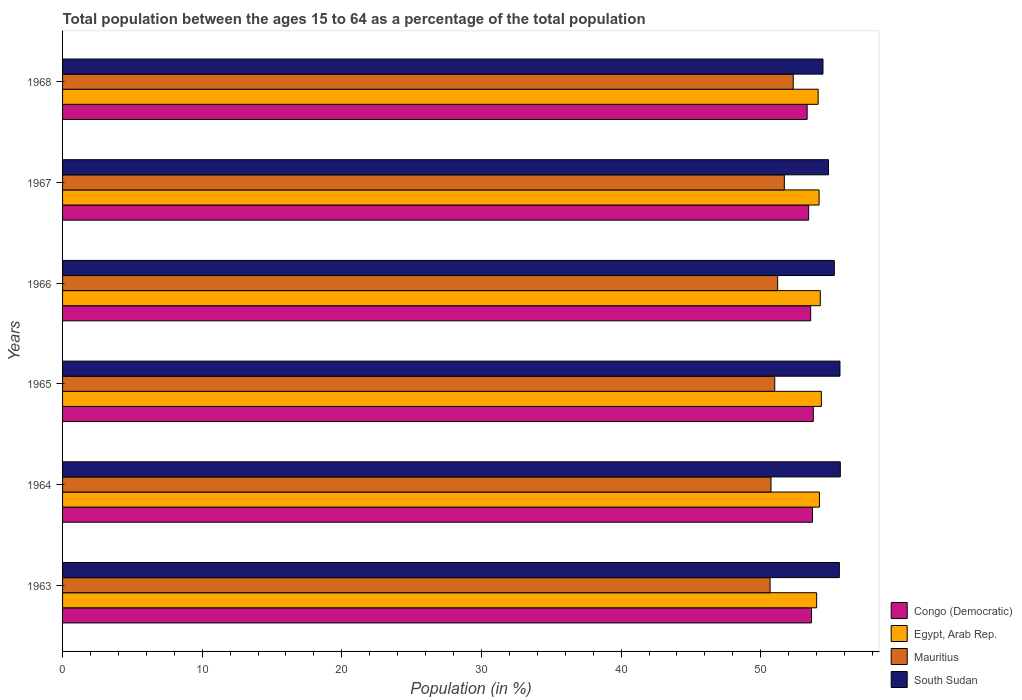Are the number of bars on each tick of the Y-axis equal?
Keep it short and to the point. Yes. How many bars are there on the 6th tick from the top?
Your answer should be compact. 4. How many bars are there on the 1st tick from the bottom?
Make the answer very short. 4. What is the label of the 1st group of bars from the top?
Keep it short and to the point. 1968. What is the percentage of the population ages 15 to 64 in South Sudan in 1964?
Your answer should be compact. 55.7. Across all years, what is the maximum percentage of the population ages 15 to 64 in Congo (Democratic)?
Ensure brevity in your answer.  53.77. Across all years, what is the minimum percentage of the population ages 15 to 64 in Egypt, Arab Rep.?
Your response must be concise. 54.01. In which year was the percentage of the population ages 15 to 64 in Congo (Democratic) maximum?
Your response must be concise. 1965. In which year was the percentage of the population ages 15 to 64 in Congo (Democratic) minimum?
Your response must be concise. 1968. What is the total percentage of the population ages 15 to 64 in Egypt, Arab Rep. in the graph?
Your response must be concise. 325.12. What is the difference between the percentage of the population ages 15 to 64 in South Sudan in 1966 and that in 1967?
Your response must be concise. 0.42. What is the difference between the percentage of the population ages 15 to 64 in Congo (Democratic) in 1967 and the percentage of the population ages 15 to 64 in Egypt, Arab Rep. in 1968?
Make the answer very short. -0.68. What is the average percentage of the population ages 15 to 64 in Congo (Democratic) per year?
Ensure brevity in your answer.  53.58. In the year 1968, what is the difference between the percentage of the population ages 15 to 64 in Egypt, Arab Rep. and percentage of the population ages 15 to 64 in Congo (Democratic)?
Keep it short and to the point. 0.79. In how many years, is the percentage of the population ages 15 to 64 in South Sudan greater than 50 ?
Your answer should be compact. 6. What is the ratio of the percentage of the population ages 15 to 64 in Egypt, Arab Rep. in 1963 to that in 1966?
Offer a very short reply. 1. Is the percentage of the population ages 15 to 64 in Egypt, Arab Rep. in 1963 less than that in 1965?
Offer a very short reply. Yes. What is the difference between the highest and the second highest percentage of the population ages 15 to 64 in Egypt, Arab Rep.?
Keep it short and to the point. 0.08. What is the difference between the highest and the lowest percentage of the population ages 15 to 64 in Egypt, Arab Rep.?
Provide a succinct answer. 0.34. In how many years, is the percentage of the population ages 15 to 64 in Congo (Democratic) greater than the average percentage of the population ages 15 to 64 in Congo (Democratic) taken over all years?
Offer a very short reply. 4. Is it the case that in every year, the sum of the percentage of the population ages 15 to 64 in South Sudan and percentage of the population ages 15 to 64 in Egypt, Arab Rep. is greater than the sum of percentage of the population ages 15 to 64 in Mauritius and percentage of the population ages 15 to 64 in Congo (Democratic)?
Provide a succinct answer. Yes. What does the 2nd bar from the top in 1966 represents?
Ensure brevity in your answer.  Mauritius. What does the 2nd bar from the bottom in 1965 represents?
Provide a succinct answer. Egypt, Arab Rep. Is it the case that in every year, the sum of the percentage of the population ages 15 to 64 in Congo (Democratic) and percentage of the population ages 15 to 64 in Egypt, Arab Rep. is greater than the percentage of the population ages 15 to 64 in Mauritius?
Offer a very short reply. Yes. Are all the bars in the graph horizontal?
Ensure brevity in your answer.  Yes. What is the difference between two consecutive major ticks on the X-axis?
Offer a very short reply. 10. Does the graph contain grids?
Make the answer very short. No. Where does the legend appear in the graph?
Keep it short and to the point. Bottom right. How many legend labels are there?
Provide a succinct answer. 4. How are the legend labels stacked?
Your answer should be very brief. Vertical. What is the title of the graph?
Offer a very short reply. Total population between the ages 15 to 64 as a percentage of the total population. What is the Population (in %) in Congo (Democratic) in 1963?
Your answer should be very brief. 53.64. What is the Population (in %) of Egypt, Arab Rep. in 1963?
Your answer should be very brief. 54.01. What is the Population (in %) of Mauritius in 1963?
Provide a short and direct response. 50.67. What is the Population (in %) of South Sudan in 1963?
Keep it short and to the point. 55.63. What is the Population (in %) of Congo (Democratic) in 1964?
Your response must be concise. 53.71. What is the Population (in %) in Egypt, Arab Rep. in 1964?
Offer a very short reply. 54.21. What is the Population (in %) in Mauritius in 1964?
Make the answer very short. 50.74. What is the Population (in %) in South Sudan in 1964?
Your answer should be very brief. 55.7. What is the Population (in %) of Congo (Democratic) in 1965?
Ensure brevity in your answer.  53.77. What is the Population (in %) in Egypt, Arab Rep. in 1965?
Your response must be concise. 54.34. What is the Population (in %) of Mauritius in 1965?
Your response must be concise. 51.01. What is the Population (in %) in South Sudan in 1965?
Your answer should be compact. 55.68. What is the Population (in %) in Congo (Democratic) in 1966?
Your answer should be compact. 53.58. What is the Population (in %) in Egypt, Arab Rep. in 1966?
Your answer should be very brief. 54.27. What is the Population (in %) of Mauritius in 1966?
Your answer should be compact. 51.21. What is the Population (in %) of South Sudan in 1966?
Give a very brief answer. 55.27. What is the Population (in %) in Congo (Democratic) in 1967?
Offer a terse response. 53.43. What is the Population (in %) of Egypt, Arab Rep. in 1967?
Keep it short and to the point. 54.18. What is the Population (in %) in Mauritius in 1967?
Make the answer very short. 51.69. What is the Population (in %) in South Sudan in 1967?
Provide a short and direct response. 54.85. What is the Population (in %) of Congo (Democratic) in 1968?
Offer a very short reply. 53.33. What is the Population (in %) in Egypt, Arab Rep. in 1968?
Your answer should be compact. 54.11. What is the Population (in %) of Mauritius in 1968?
Provide a short and direct response. 52.33. What is the Population (in %) of South Sudan in 1968?
Provide a short and direct response. 54.46. Across all years, what is the maximum Population (in %) in Congo (Democratic)?
Your answer should be compact. 53.77. Across all years, what is the maximum Population (in %) in Egypt, Arab Rep.?
Your answer should be very brief. 54.34. Across all years, what is the maximum Population (in %) in Mauritius?
Provide a short and direct response. 52.33. Across all years, what is the maximum Population (in %) in South Sudan?
Ensure brevity in your answer.  55.7. Across all years, what is the minimum Population (in %) of Congo (Democratic)?
Provide a short and direct response. 53.33. Across all years, what is the minimum Population (in %) of Egypt, Arab Rep.?
Give a very brief answer. 54.01. Across all years, what is the minimum Population (in %) of Mauritius?
Provide a succinct answer. 50.67. Across all years, what is the minimum Population (in %) in South Sudan?
Your answer should be compact. 54.46. What is the total Population (in %) in Congo (Democratic) in the graph?
Provide a short and direct response. 321.45. What is the total Population (in %) in Egypt, Arab Rep. in the graph?
Your answer should be very brief. 325.12. What is the total Population (in %) in Mauritius in the graph?
Provide a short and direct response. 307.65. What is the total Population (in %) of South Sudan in the graph?
Provide a succinct answer. 331.6. What is the difference between the Population (in %) of Congo (Democratic) in 1963 and that in 1964?
Provide a succinct answer. -0.07. What is the difference between the Population (in %) in Egypt, Arab Rep. in 1963 and that in 1964?
Your answer should be compact. -0.2. What is the difference between the Population (in %) in Mauritius in 1963 and that in 1964?
Provide a short and direct response. -0.07. What is the difference between the Population (in %) in South Sudan in 1963 and that in 1964?
Your answer should be compact. -0.07. What is the difference between the Population (in %) in Congo (Democratic) in 1963 and that in 1965?
Ensure brevity in your answer.  -0.13. What is the difference between the Population (in %) of Egypt, Arab Rep. in 1963 and that in 1965?
Give a very brief answer. -0.34. What is the difference between the Population (in %) of Mauritius in 1963 and that in 1965?
Provide a succinct answer. -0.33. What is the difference between the Population (in %) in South Sudan in 1963 and that in 1965?
Your answer should be compact. -0.04. What is the difference between the Population (in %) of Congo (Democratic) in 1963 and that in 1966?
Your response must be concise. 0.06. What is the difference between the Population (in %) of Egypt, Arab Rep. in 1963 and that in 1966?
Your answer should be compact. -0.26. What is the difference between the Population (in %) of Mauritius in 1963 and that in 1966?
Provide a short and direct response. -0.54. What is the difference between the Population (in %) in South Sudan in 1963 and that in 1966?
Give a very brief answer. 0.36. What is the difference between the Population (in %) of Congo (Democratic) in 1963 and that in 1967?
Your answer should be very brief. 0.2. What is the difference between the Population (in %) of Egypt, Arab Rep. in 1963 and that in 1967?
Provide a succinct answer. -0.18. What is the difference between the Population (in %) in Mauritius in 1963 and that in 1967?
Your answer should be compact. -1.02. What is the difference between the Population (in %) in South Sudan in 1963 and that in 1967?
Ensure brevity in your answer.  0.78. What is the difference between the Population (in %) in Congo (Democratic) in 1963 and that in 1968?
Provide a short and direct response. 0.31. What is the difference between the Population (in %) of Egypt, Arab Rep. in 1963 and that in 1968?
Your response must be concise. -0.11. What is the difference between the Population (in %) in Mauritius in 1963 and that in 1968?
Provide a succinct answer. -1.66. What is the difference between the Population (in %) of South Sudan in 1963 and that in 1968?
Your response must be concise. 1.17. What is the difference between the Population (in %) of Congo (Democratic) in 1964 and that in 1965?
Offer a very short reply. -0.06. What is the difference between the Population (in %) in Egypt, Arab Rep. in 1964 and that in 1965?
Provide a succinct answer. -0.14. What is the difference between the Population (in %) of Mauritius in 1964 and that in 1965?
Make the answer very short. -0.27. What is the difference between the Population (in %) of South Sudan in 1964 and that in 1965?
Give a very brief answer. 0.02. What is the difference between the Population (in %) in Congo (Democratic) in 1964 and that in 1966?
Offer a very short reply. 0.13. What is the difference between the Population (in %) of Egypt, Arab Rep. in 1964 and that in 1966?
Make the answer very short. -0.06. What is the difference between the Population (in %) of Mauritius in 1964 and that in 1966?
Make the answer very short. -0.48. What is the difference between the Population (in %) in South Sudan in 1964 and that in 1966?
Ensure brevity in your answer.  0.43. What is the difference between the Population (in %) in Congo (Democratic) in 1964 and that in 1967?
Give a very brief answer. 0.27. What is the difference between the Population (in %) in Egypt, Arab Rep. in 1964 and that in 1967?
Keep it short and to the point. 0.03. What is the difference between the Population (in %) in Mauritius in 1964 and that in 1967?
Provide a short and direct response. -0.95. What is the difference between the Population (in %) of South Sudan in 1964 and that in 1967?
Offer a very short reply. 0.85. What is the difference between the Population (in %) of Congo (Democratic) in 1964 and that in 1968?
Give a very brief answer. 0.38. What is the difference between the Population (in %) in Egypt, Arab Rep. in 1964 and that in 1968?
Your answer should be very brief. 0.09. What is the difference between the Population (in %) of Mauritius in 1964 and that in 1968?
Make the answer very short. -1.59. What is the difference between the Population (in %) in South Sudan in 1964 and that in 1968?
Give a very brief answer. 1.24. What is the difference between the Population (in %) of Congo (Democratic) in 1965 and that in 1966?
Make the answer very short. 0.19. What is the difference between the Population (in %) in Egypt, Arab Rep. in 1965 and that in 1966?
Keep it short and to the point. 0.08. What is the difference between the Population (in %) of Mauritius in 1965 and that in 1966?
Offer a terse response. -0.21. What is the difference between the Population (in %) in South Sudan in 1965 and that in 1966?
Your answer should be compact. 0.41. What is the difference between the Population (in %) of Congo (Democratic) in 1965 and that in 1967?
Your response must be concise. 0.33. What is the difference between the Population (in %) of Egypt, Arab Rep. in 1965 and that in 1967?
Your answer should be very brief. 0.16. What is the difference between the Population (in %) of Mauritius in 1965 and that in 1967?
Provide a short and direct response. -0.69. What is the difference between the Population (in %) in South Sudan in 1965 and that in 1967?
Give a very brief answer. 0.82. What is the difference between the Population (in %) in Congo (Democratic) in 1965 and that in 1968?
Make the answer very short. 0.44. What is the difference between the Population (in %) in Egypt, Arab Rep. in 1965 and that in 1968?
Offer a terse response. 0.23. What is the difference between the Population (in %) of Mauritius in 1965 and that in 1968?
Offer a terse response. -1.32. What is the difference between the Population (in %) in South Sudan in 1965 and that in 1968?
Offer a very short reply. 1.22. What is the difference between the Population (in %) of Congo (Democratic) in 1966 and that in 1967?
Offer a terse response. 0.14. What is the difference between the Population (in %) in Egypt, Arab Rep. in 1966 and that in 1967?
Make the answer very short. 0.09. What is the difference between the Population (in %) in Mauritius in 1966 and that in 1967?
Give a very brief answer. -0.48. What is the difference between the Population (in %) in South Sudan in 1966 and that in 1967?
Keep it short and to the point. 0.42. What is the difference between the Population (in %) in Congo (Democratic) in 1966 and that in 1968?
Provide a short and direct response. 0.25. What is the difference between the Population (in %) of Egypt, Arab Rep. in 1966 and that in 1968?
Give a very brief answer. 0.15. What is the difference between the Population (in %) in Mauritius in 1966 and that in 1968?
Your answer should be very brief. -1.11. What is the difference between the Population (in %) in South Sudan in 1966 and that in 1968?
Your answer should be very brief. 0.81. What is the difference between the Population (in %) of Congo (Democratic) in 1967 and that in 1968?
Offer a terse response. 0.11. What is the difference between the Population (in %) in Egypt, Arab Rep. in 1967 and that in 1968?
Offer a very short reply. 0.07. What is the difference between the Population (in %) in Mauritius in 1967 and that in 1968?
Your answer should be very brief. -0.64. What is the difference between the Population (in %) of South Sudan in 1967 and that in 1968?
Ensure brevity in your answer.  0.39. What is the difference between the Population (in %) of Congo (Democratic) in 1963 and the Population (in %) of Egypt, Arab Rep. in 1964?
Make the answer very short. -0.57. What is the difference between the Population (in %) in Congo (Democratic) in 1963 and the Population (in %) in Mauritius in 1964?
Your answer should be compact. 2.9. What is the difference between the Population (in %) of Congo (Democratic) in 1963 and the Population (in %) of South Sudan in 1964?
Your answer should be compact. -2.06. What is the difference between the Population (in %) of Egypt, Arab Rep. in 1963 and the Population (in %) of Mauritius in 1964?
Your answer should be very brief. 3.27. What is the difference between the Population (in %) of Egypt, Arab Rep. in 1963 and the Population (in %) of South Sudan in 1964?
Ensure brevity in your answer.  -1.7. What is the difference between the Population (in %) of Mauritius in 1963 and the Population (in %) of South Sudan in 1964?
Your answer should be very brief. -5.03. What is the difference between the Population (in %) of Congo (Democratic) in 1963 and the Population (in %) of Egypt, Arab Rep. in 1965?
Give a very brief answer. -0.71. What is the difference between the Population (in %) of Congo (Democratic) in 1963 and the Population (in %) of Mauritius in 1965?
Your answer should be very brief. 2.63. What is the difference between the Population (in %) of Congo (Democratic) in 1963 and the Population (in %) of South Sudan in 1965?
Provide a succinct answer. -2.04. What is the difference between the Population (in %) of Egypt, Arab Rep. in 1963 and the Population (in %) of Mauritius in 1965?
Ensure brevity in your answer.  3. What is the difference between the Population (in %) in Egypt, Arab Rep. in 1963 and the Population (in %) in South Sudan in 1965?
Your response must be concise. -1.67. What is the difference between the Population (in %) of Mauritius in 1963 and the Population (in %) of South Sudan in 1965?
Provide a succinct answer. -5. What is the difference between the Population (in %) of Congo (Democratic) in 1963 and the Population (in %) of Egypt, Arab Rep. in 1966?
Your answer should be very brief. -0.63. What is the difference between the Population (in %) of Congo (Democratic) in 1963 and the Population (in %) of Mauritius in 1966?
Provide a short and direct response. 2.42. What is the difference between the Population (in %) of Congo (Democratic) in 1963 and the Population (in %) of South Sudan in 1966?
Give a very brief answer. -1.63. What is the difference between the Population (in %) in Egypt, Arab Rep. in 1963 and the Population (in %) in Mauritius in 1966?
Your answer should be compact. 2.79. What is the difference between the Population (in %) in Egypt, Arab Rep. in 1963 and the Population (in %) in South Sudan in 1966?
Provide a short and direct response. -1.27. What is the difference between the Population (in %) in Mauritius in 1963 and the Population (in %) in South Sudan in 1966?
Your answer should be very brief. -4.6. What is the difference between the Population (in %) of Congo (Democratic) in 1963 and the Population (in %) of Egypt, Arab Rep. in 1967?
Provide a short and direct response. -0.54. What is the difference between the Population (in %) of Congo (Democratic) in 1963 and the Population (in %) of Mauritius in 1967?
Provide a succinct answer. 1.95. What is the difference between the Population (in %) in Congo (Democratic) in 1963 and the Population (in %) in South Sudan in 1967?
Offer a terse response. -1.22. What is the difference between the Population (in %) in Egypt, Arab Rep. in 1963 and the Population (in %) in Mauritius in 1967?
Your answer should be compact. 2.31. What is the difference between the Population (in %) of Egypt, Arab Rep. in 1963 and the Population (in %) of South Sudan in 1967?
Ensure brevity in your answer.  -0.85. What is the difference between the Population (in %) of Mauritius in 1963 and the Population (in %) of South Sudan in 1967?
Your answer should be very brief. -4.18. What is the difference between the Population (in %) in Congo (Democratic) in 1963 and the Population (in %) in Egypt, Arab Rep. in 1968?
Offer a very short reply. -0.48. What is the difference between the Population (in %) of Congo (Democratic) in 1963 and the Population (in %) of Mauritius in 1968?
Make the answer very short. 1.31. What is the difference between the Population (in %) in Congo (Democratic) in 1963 and the Population (in %) in South Sudan in 1968?
Your answer should be compact. -0.82. What is the difference between the Population (in %) in Egypt, Arab Rep. in 1963 and the Population (in %) in Mauritius in 1968?
Keep it short and to the point. 1.68. What is the difference between the Population (in %) in Egypt, Arab Rep. in 1963 and the Population (in %) in South Sudan in 1968?
Provide a short and direct response. -0.45. What is the difference between the Population (in %) of Mauritius in 1963 and the Population (in %) of South Sudan in 1968?
Offer a very short reply. -3.79. What is the difference between the Population (in %) of Congo (Democratic) in 1964 and the Population (in %) of Egypt, Arab Rep. in 1965?
Your answer should be compact. -0.64. What is the difference between the Population (in %) in Congo (Democratic) in 1964 and the Population (in %) in Mauritius in 1965?
Offer a terse response. 2.7. What is the difference between the Population (in %) of Congo (Democratic) in 1964 and the Population (in %) of South Sudan in 1965?
Provide a short and direct response. -1.97. What is the difference between the Population (in %) in Egypt, Arab Rep. in 1964 and the Population (in %) in Mauritius in 1965?
Keep it short and to the point. 3.2. What is the difference between the Population (in %) of Egypt, Arab Rep. in 1964 and the Population (in %) of South Sudan in 1965?
Your answer should be compact. -1.47. What is the difference between the Population (in %) of Mauritius in 1964 and the Population (in %) of South Sudan in 1965?
Ensure brevity in your answer.  -4.94. What is the difference between the Population (in %) of Congo (Democratic) in 1964 and the Population (in %) of Egypt, Arab Rep. in 1966?
Keep it short and to the point. -0.56. What is the difference between the Population (in %) in Congo (Democratic) in 1964 and the Population (in %) in Mauritius in 1966?
Provide a succinct answer. 2.49. What is the difference between the Population (in %) in Congo (Democratic) in 1964 and the Population (in %) in South Sudan in 1966?
Keep it short and to the point. -1.56. What is the difference between the Population (in %) in Egypt, Arab Rep. in 1964 and the Population (in %) in Mauritius in 1966?
Offer a terse response. 2.99. What is the difference between the Population (in %) in Egypt, Arab Rep. in 1964 and the Population (in %) in South Sudan in 1966?
Your answer should be compact. -1.06. What is the difference between the Population (in %) of Mauritius in 1964 and the Population (in %) of South Sudan in 1966?
Your answer should be very brief. -4.53. What is the difference between the Population (in %) in Congo (Democratic) in 1964 and the Population (in %) in Egypt, Arab Rep. in 1967?
Your answer should be compact. -0.47. What is the difference between the Population (in %) in Congo (Democratic) in 1964 and the Population (in %) in Mauritius in 1967?
Provide a succinct answer. 2.02. What is the difference between the Population (in %) of Congo (Democratic) in 1964 and the Population (in %) of South Sudan in 1967?
Offer a terse response. -1.15. What is the difference between the Population (in %) of Egypt, Arab Rep. in 1964 and the Population (in %) of Mauritius in 1967?
Keep it short and to the point. 2.52. What is the difference between the Population (in %) in Egypt, Arab Rep. in 1964 and the Population (in %) in South Sudan in 1967?
Make the answer very short. -0.65. What is the difference between the Population (in %) of Mauritius in 1964 and the Population (in %) of South Sudan in 1967?
Offer a terse response. -4.12. What is the difference between the Population (in %) in Congo (Democratic) in 1964 and the Population (in %) in Egypt, Arab Rep. in 1968?
Ensure brevity in your answer.  -0.41. What is the difference between the Population (in %) of Congo (Democratic) in 1964 and the Population (in %) of Mauritius in 1968?
Make the answer very short. 1.38. What is the difference between the Population (in %) in Congo (Democratic) in 1964 and the Population (in %) in South Sudan in 1968?
Your response must be concise. -0.75. What is the difference between the Population (in %) in Egypt, Arab Rep. in 1964 and the Population (in %) in Mauritius in 1968?
Give a very brief answer. 1.88. What is the difference between the Population (in %) of Egypt, Arab Rep. in 1964 and the Population (in %) of South Sudan in 1968?
Offer a very short reply. -0.25. What is the difference between the Population (in %) in Mauritius in 1964 and the Population (in %) in South Sudan in 1968?
Ensure brevity in your answer.  -3.72. What is the difference between the Population (in %) of Congo (Democratic) in 1965 and the Population (in %) of Egypt, Arab Rep. in 1966?
Offer a terse response. -0.5. What is the difference between the Population (in %) of Congo (Democratic) in 1965 and the Population (in %) of Mauritius in 1966?
Give a very brief answer. 2.55. What is the difference between the Population (in %) of Congo (Democratic) in 1965 and the Population (in %) of South Sudan in 1966?
Give a very brief answer. -1.5. What is the difference between the Population (in %) of Egypt, Arab Rep. in 1965 and the Population (in %) of Mauritius in 1966?
Make the answer very short. 3.13. What is the difference between the Population (in %) of Egypt, Arab Rep. in 1965 and the Population (in %) of South Sudan in 1966?
Keep it short and to the point. -0.93. What is the difference between the Population (in %) of Mauritius in 1965 and the Population (in %) of South Sudan in 1966?
Make the answer very short. -4.27. What is the difference between the Population (in %) of Congo (Democratic) in 1965 and the Population (in %) of Egypt, Arab Rep. in 1967?
Offer a terse response. -0.42. What is the difference between the Population (in %) of Congo (Democratic) in 1965 and the Population (in %) of Mauritius in 1967?
Provide a short and direct response. 2.07. What is the difference between the Population (in %) of Congo (Democratic) in 1965 and the Population (in %) of South Sudan in 1967?
Your answer should be compact. -1.09. What is the difference between the Population (in %) in Egypt, Arab Rep. in 1965 and the Population (in %) in Mauritius in 1967?
Provide a short and direct response. 2.65. What is the difference between the Population (in %) in Egypt, Arab Rep. in 1965 and the Population (in %) in South Sudan in 1967?
Provide a short and direct response. -0.51. What is the difference between the Population (in %) in Mauritius in 1965 and the Population (in %) in South Sudan in 1967?
Provide a succinct answer. -3.85. What is the difference between the Population (in %) in Congo (Democratic) in 1965 and the Population (in %) in Egypt, Arab Rep. in 1968?
Give a very brief answer. -0.35. What is the difference between the Population (in %) of Congo (Democratic) in 1965 and the Population (in %) of Mauritius in 1968?
Your answer should be very brief. 1.44. What is the difference between the Population (in %) of Congo (Democratic) in 1965 and the Population (in %) of South Sudan in 1968?
Offer a terse response. -0.69. What is the difference between the Population (in %) in Egypt, Arab Rep. in 1965 and the Population (in %) in Mauritius in 1968?
Your response must be concise. 2.01. What is the difference between the Population (in %) in Egypt, Arab Rep. in 1965 and the Population (in %) in South Sudan in 1968?
Make the answer very short. -0.12. What is the difference between the Population (in %) of Mauritius in 1965 and the Population (in %) of South Sudan in 1968?
Offer a very short reply. -3.46. What is the difference between the Population (in %) of Congo (Democratic) in 1966 and the Population (in %) of Egypt, Arab Rep. in 1967?
Your answer should be very brief. -0.6. What is the difference between the Population (in %) in Congo (Democratic) in 1966 and the Population (in %) in Mauritius in 1967?
Your response must be concise. 1.89. What is the difference between the Population (in %) in Congo (Democratic) in 1966 and the Population (in %) in South Sudan in 1967?
Give a very brief answer. -1.27. What is the difference between the Population (in %) of Egypt, Arab Rep. in 1966 and the Population (in %) of Mauritius in 1967?
Give a very brief answer. 2.58. What is the difference between the Population (in %) of Egypt, Arab Rep. in 1966 and the Population (in %) of South Sudan in 1967?
Ensure brevity in your answer.  -0.59. What is the difference between the Population (in %) of Mauritius in 1966 and the Population (in %) of South Sudan in 1967?
Keep it short and to the point. -3.64. What is the difference between the Population (in %) of Congo (Democratic) in 1966 and the Population (in %) of Egypt, Arab Rep. in 1968?
Offer a very short reply. -0.54. What is the difference between the Population (in %) in Congo (Democratic) in 1966 and the Population (in %) in Mauritius in 1968?
Offer a very short reply. 1.25. What is the difference between the Population (in %) of Congo (Democratic) in 1966 and the Population (in %) of South Sudan in 1968?
Your answer should be very brief. -0.88. What is the difference between the Population (in %) in Egypt, Arab Rep. in 1966 and the Population (in %) in Mauritius in 1968?
Make the answer very short. 1.94. What is the difference between the Population (in %) of Egypt, Arab Rep. in 1966 and the Population (in %) of South Sudan in 1968?
Your answer should be very brief. -0.19. What is the difference between the Population (in %) of Mauritius in 1966 and the Population (in %) of South Sudan in 1968?
Ensure brevity in your answer.  -3.25. What is the difference between the Population (in %) in Congo (Democratic) in 1967 and the Population (in %) in Egypt, Arab Rep. in 1968?
Make the answer very short. -0.68. What is the difference between the Population (in %) in Congo (Democratic) in 1967 and the Population (in %) in Mauritius in 1968?
Keep it short and to the point. 1.11. What is the difference between the Population (in %) in Congo (Democratic) in 1967 and the Population (in %) in South Sudan in 1968?
Give a very brief answer. -1.03. What is the difference between the Population (in %) in Egypt, Arab Rep. in 1967 and the Population (in %) in Mauritius in 1968?
Offer a terse response. 1.85. What is the difference between the Population (in %) in Egypt, Arab Rep. in 1967 and the Population (in %) in South Sudan in 1968?
Ensure brevity in your answer.  -0.28. What is the difference between the Population (in %) in Mauritius in 1967 and the Population (in %) in South Sudan in 1968?
Keep it short and to the point. -2.77. What is the average Population (in %) in Congo (Democratic) per year?
Offer a very short reply. 53.58. What is the average Population (in %) of Egypt, Arab Rep. per year?
Keep it short and to the point. 54.19. What is the average Population (in %) of Mauritius per year?
Offer a very short reply. 51.28. What is the average Population (in %) in South Sudan per year?
Make the answer very short. 55.27. In the year 1963, what is the difference between the Population (in %) in Congo (Democratic) and Population (in %) in Egypt, Arab Rep.?
Keep it short and to the point. -0.37. In the year 1963, what is the difference between the Population (in %) of Congo (Democratic) and Population (in %) of Mauritius?
Ensure brevity in your answer.  2.96. In the year 1963, what is the difference between the Population (in %) of Congo (Democratic) and Population (in %) of South Sudan?
Ensure brevity in your answer.  -2. In the year 1963, what is the difference between the Population (in %) of Egypt, Arab Rep. and Population (in %) of Mauritius?
Ensure brevity in your answer.  3.33. In the year 1963, what is the difference between the Population (in %) of Egypt, Arab Rep. and Population (in %) of South Sudan?
Provide a short and direct response. -1.63. In the year 1963, what is the difference between the Population (in %) in Mauritius and Population (in %) in South Sudan?
Give a very brief answer. -4.96. In the year 1964, what is the difference between the Population (in %) of Congo (Democratic) and Population (in %) of Egypt, Arab Rep.?
Your response must be concise. -0.5. In the year 1964, what is the difference between the Population (in %) of Congo (Democratic) and Population (in %) of Mauritius?
Provide a short and direct response. 2.97. In the year 1964, what is the difference between the Population (in %) of Congo (Democratic) and Population (in %) of South Sudan?
Your answer should be compact. -1.99. In the year 1964, what is the difference between the Population (in %) in Egypt, Arab Rep. and Population (in %) in Mauritius?
Provide a short and direct response. 3.47. In the year 1964, what is the difference between the Population (in %) in Egypt, Arab Rep. and Population (in %) in South Sudan?
Ensure brevity in your answer.  -1.49. In the year 1964, what is the difference between the Population (in %) in Mauritius and Population (in %) in South Sudan?
Make the answer very short. -4.96. In the year 1965, what is the difference between the Population (in %) in Congo (Democratic) and Population (in %) in Egypt, Arab Rep.?
Offer a very short reply. -0.58. In the year 1965, what is the difference between the Population (in %) in Congo (Democratic) and Population (in %) in Mauritius?
Make the answer very short. 2.76. In the year 1965, what is the difference between the Population (in %) in Congo (Democratic) and Population (in %) in South Sudan?
Provide a short and direct response. -1.91. In the year 1965, what is the difference between the Population (in %) in Egypt, Arab Rep. and Population (in %) in Mauritius?
Give a very brief answer. 3.34. In the year 1965, what is the difference between the Population (in %) of Egypt, Arab Rep. and Population (in %) of South Sudan?
Give a very brief answer. -1.33. In the year 1965, what is the difference between the Population (in %) of Mauritius and Population (in %) of South Sudan?
Provide a succinct answer. -4.67. In the year 1966, what is the difference between the Population (in %) in Congo (Democratic) and Population (in %) in Egypt, Arab Rep.?
Ensure brevity in your answer.  -0.69. In the year 1966, what is the difference between the Population (in %) of Congo (Democratic) and Population (in %) of Mauritius?
Offer a very short reply. 2.36. In the year 1966, what is the difference between the Population (in %) in Congo (Democratic) and Population (in %) in South Sudan?
Offer a terse response. -1.69. In the year 1966, what is the difference between the Population (in %) of Egypt, Arab Rep. and Population (in %) of Mauritius?
Ensure brevity in your answer.  3.05. In the year 1966, what is the difference between the Population (in %) of Egypt, Arab Rep. and Population (in %) of South Sudan?
Make the answer very short. -1. In the year 1966, what is the difference between the Population (in %) of Mauritius and Population (in %) of South Sudan?
Ensure brevity in your answer.  -4.06. In the year 1967, what is the difference between the Population (in %) of Congo (Democratic) and Population (in %) of Egypt, Arab Rep.?
Make the answer very short. -0.75. In the year 1967, what is the difference between the Population (in %) of Congo (Democratic) and Population (in %) of Mauritius?
Keep it short and to the point. 1.74. In the year 1967, what is the difference between the Population (in %) in Congo (Democratic) and Population (in %) in South Sudan?
Your answer should be compact. -1.42. In the year 1967, what is the difference between the Population (in %) in Egypt, Arab Rep. and Population (in %) in Mauritius?
Give a very brief answer. 2.49. In the year 1967, what is the difference between the Population (in %) in Egypt, Arab Rep. and Population (in %) in South Sudan?
Offer a very short reply. -0.67. In the year 1967, what is the difference between the Population (in %) in Mauritius and Population (in %) in South Sudan?
Give a very brief answer. -3.16. In the year 1968, what is the difference between the Population (in %) in Congo (Democratic) and Population (in %) in Egypt, Arab Rep.?
Provide a short and direct response. -0.79. In the year 1968, what is the difference between the Population (in %) of Congo (Democratic) and Population (in %) of Mauritius?
Make the answer very short. 1. In the year 1968, what is the difference between the Population (in %) of Congo (Democratic) and Population (in %) of South Sudan?
Your answer should be very brief. -1.13. In the year 1968, what is the difference between the Population (in %) of Egypt, Arab Rep. and Population (in %) of Mauritius?
Your answer should be very brief. 1.79. In the year 1968, what is the difference between the Population (in %) in Egypt, Arab Rep. and Population (in %) in South Sudan?
Make the answer very short. -0.35. In the year 1968, what is the difference between the Population (in %) in Mauritius and Population (in %) in South Sudan?
Your response must be concise. -2.13. What is the ratio of the Population (in %) of Egypt, Arab Rep. in 1963 to that in 1964?
Keep it short and to the point. 1. What is the ratio of the Population (in %) of Mauritius in 1963 to that in 1964?
Make the answer very short. 1. What is the ratio of the Population (in %) in South Sudan in 1963 to that in 1964?
Ensure brevity in your answer.  1. What is the ratio of the Population (in %) of Congo (Democratic) in 1963 to that in 1965?
Give a very brief answer. 1. What is the ratio of the Population (in %) in Egypt, Arab Rep. in 1963 to that in 1965?
Provide a succinct answer. 0.99. What is the ratio of the Population (in %) of South Sudan in 1963 to that in 1965?
Keep it short and to the point. 1. What is the ratio of the Population (in %) of Congo (Democratic) in 1963 to that in 1966?
Offer a very short reply. 1. What is the ratio of the Population (in %) in South Sudan in 1963 to that in 1966?
Your answer should be compact. 1.01. What is the ratio of the Population (in %) in Congo (Democratic) in 1963 to that in 1967?
Your answer should be compact. 1. What is the ratio of the Population (in %) in Mauritius in 1963 to that in 1967?
Keep it short and to the point. 0.98. What is the ratio of the Population (in %) of South Sudan in 1963 to that in 1967?
Make the answer very short. 1.01. What is the ratio of the Population (in %) in Mauritius in 1963 to that in 1968?
Keep it short and to the point. 0.97. What is the ratio of the Population (in %) of South Sudan in 1963 to that in 1968?
Ensure brevity in your answer.  1.02. What is the ratio of the Population (in %) in Congo (Democratic) in 1964 to that in 1965?
Your answer should be very brief. 1. What is the ratio of the Population (in %) in Egypt, Arab Rep. in 1964 to that in 1965?
Make the answer very short. 1. What is the ratio of the Population (in %) of South Sudan in 1964 to that in 1965?
Provide a short and direct response. 1. What is the ratio of the Population (in %) of Congo (Democratic) in 1964 to that in 1966?
Offer a very short reply. 1. What is the ratio of the Population (in %) of Egypt, Arab Rep. in 1964 to that in 1966?
Provide a short and direct response. 1. What is the ratio of the Population (in %) in Mauritius in 1964 to that in 1966?
Ensure brevity in your answer.  0.99. What is the ratio of the Population (in %) of South Sudan in 1964 to that in 1966?
Offer a terse response. 1.01. What is the ratio of the Population (in %) of Congo (Democratic) in 1964 to that in 1967?
Make the answer very short. 1.01. What is the ratio of the Population (in %) in Mauritius in 1964 to that in 1967?
Ensure brevity in your answer.  0.98. What is the ratio of the Population (in %) of South Sudan in 1964 to that in 1967?
Make the answer very short. 1.02. What is the ratio of the Population (in %) in Congo (Democratic) in 1964 to that in 1968?
Ensure brevity in your answer.  1.01. What is the ratio of the Population (in %) in Egypt, Arab Rep. in 1964 to that in 1968?
Offer a terse response. 1. What is the ratio of the Population (in %) of Mauritius in 1964 to that in 1968?
Keep it short and to the point. 0.97. What is the ratio of the Population (in %) in South Sudan in 1964 to that in 1968?
Provide a succinct answer. 1.02. What is the ratio of the Population (in %) of Congo (Democratic) in 1965 to that in 1966?
Offer a terse response. 1. What is the ratio of the Population (in %) of Egypt, Arab Rep. in 1965 to that in 1966?
Ensure brevity in your answer.  1. What is the ratio of the Population (in %) in South Sudan in 1965 to that in 1966?
Your answer should be very brief. 1.01. What is the ratio of the Population (in %) in Egypt, Arab Rep. in 1965 to that in 1967?
Make the answer very short. 1. What is the ratio of the Population (in %) of Mauritius in 1965 to that in 1967?
Your answer should be very brief. 0.99. What is the ratio of the Population (in %) of Congo (Democratic) in 1965 to that in 1968?
Your answer should be compact. 1.01. What is the ratio of the Population (in %) in Mauritius in 1965 to that in 1968?
Give a very brief answer. 0.97. What is the ratio of the Population (in %) of South Sudan in 1965 to that in 1968?
Offer a very short reply. 1.02. What is the ratio of the Population (in %) in Egypt, Arab Rep. in 1966 to that in 1967?
Your answer should be very brief. 1. What is the ratio of the Population (in %) of Mauritius in 1966 to that in 1967?
Make the answer very short. 0.99. What is the ratio of the Population (in %) in South Sudan in 1966 to that in 1967?
Offer a terse response. 1.01. What is the ratio of the Population (in %) of Egypt, Arab Rep. in 1966 to that in 1968?
Keep it short and to the point. 1. What is the ratio of the Population (in %) in Mauritius in 1966 to that in 1968?
Ensure brevity in your answer.  0.98. What is the ratio of the Population (in %) in South Sudan in 1966 to that in 1968?
Offer a terse response. 1.01. What is the difference between the highest and the second highest Population (in %) in Congo (Democratic)?
Give a very brief answer. 0.06. What is the difference between the highest and the second highest Population (in %) in Egypt, Arab Rep.?
Keep it short and to the point. 0.08. What is the difference between the highest and the second highest Population (in %) in Mauritius?
Offer a terse response. 0.64. What is the difference between the highest and the second highest Population (in %) of South Sudan?
Give a very brief answer. 0.02. What is the difference between the highest and the lowest Population (in %) in Congo (Democratic)?
Offer a very short reply. 0.44. What is the difference between the highest and the lowest Population (in %) in Egypt, Arab Rep.?
Make the answer very short. 0.34. What is the difference between the highest and the lowest Population (in %) in Mauritius?
Keep it short and to the point. 1.66. What is the difference between the highest and the lowest Population (in %) in South Sudan?
Keep it short and to the point. 1.24. 